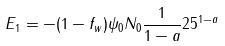Convert formula to latex. <formula><loc_0><loc_0><loc_500><loc_500>E _ { 1 } = - ( 1 - f _ { w } ) \psi _ { 0 } N _ { 0 } \frac { 1 } { 1 - a } 2 5 ^ { 1 - a } \,</formula> 